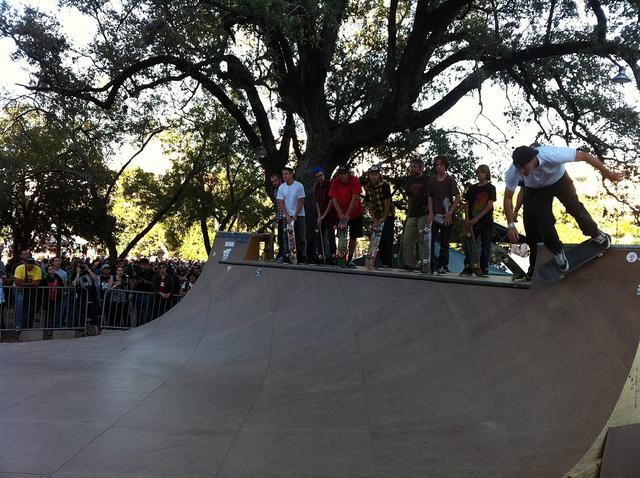How many people are on the ramp? Please explain your reasoning. many. There are more than several people on the ramp. 